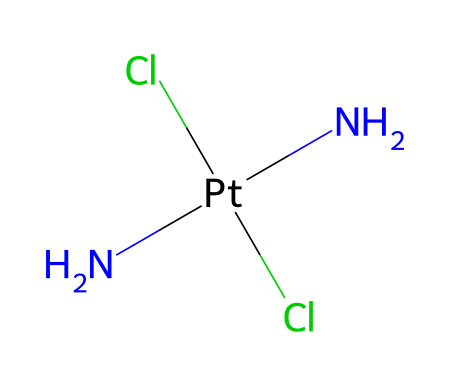What is the central metal atom in cis-platin? The chemical formula N[Pt](N)(Cl)Cl shows that the central metal atom is platinum, indicated by "Pt."
Answer: platinum How many chloride ions are present in cis-platin? The SMILES notation includes two "Cl" representations, indicating there are two chloride ions connected to the platinum.
Answer: two What is the coordination number of the platinum in cis-platin? In this structure, platinum is bonded to four atoms (two nitrogen and two chloride), giving it a coordination number of four.
Answer: four Can cis-platin exhibit geometric isomerism? The presence of two identical ligands (two chloride ions) and two different ligands (two amine groups) around the central platinum allows for geometric isomerism.
Answer: yes What type of isomerism is displayed by cis-platin? Given the structure has different arrangements of the ligands (cis and trans), it exhibits geometric isomerism, also known as cis-trans isomerism.
Answer: geometric How many nitrogen atoms are present in the cis-platin structure? The SMILES representation indicates "N[Pt](N)(Cl)Cl", showing that there are two nitrogen atoms connected to platinum.
Answer: two 